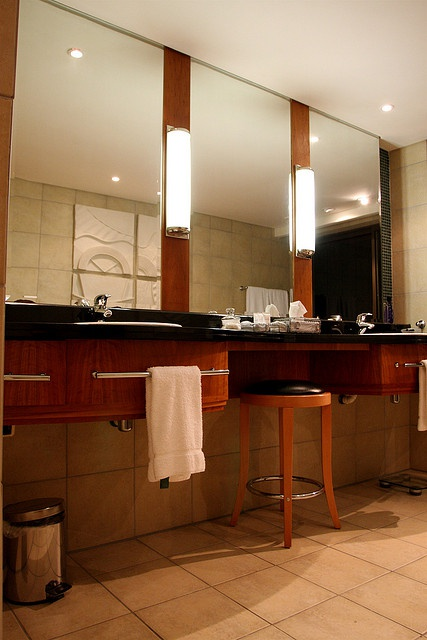Describe the objects in this image and their specific colors. I can see chair in maroon and black tones, sink in maroon, black, white, and tan tones, sink in maroon, black, ivory, and tan tones, and sink in maroon, gray, and black tones in this image. 